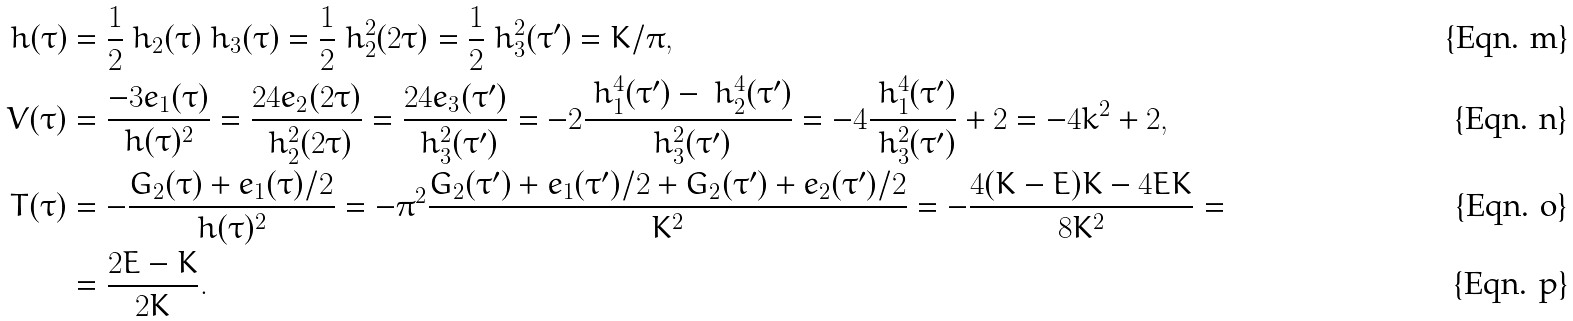<formula> <loc_0><loc_0><loc_500><loc_500>h ( \tau ) & = \frac { 1 } { 2 } \ h _ { 2 } ( \tau ) \ h _ { 3 } ( \tau ) = \frac { 1 } { 2 } \ h _ { 2 } ^ { 2 } ( 2 \tau ) = \frac { 1 } { 2 } \ h _ { 3 } ^ { 2 } ( \tau ^ { \prime } ) = K / \pi , \\ V ( \tau ) & = \frac { - 3 e _ { 1 } ( \tau ) } { h ( \tau ) ^ { 2 } } = \frac { 2 4 e _ { 2 } ( 2 \tau ) } { \ h _ { 2 } ^ { 2 } ( 2 \tau ) } = \frac { 2 4 e _ { 3 } ( \tau ^ { \prime } ) } { \ h _ { 3 } ^ { 2 } ( \tau ^ { \prime } ) } = - 2 \frac { \ h _ { 1 } ^ { 4 } ( \tau ^ { \prime } ) - \ h _ { 2 } ^ { 4 } ( \tau ^ { \prime } ) } { \ h _ { 3 } ^ { 2 } ( \tau ^ { \prime } ) } = - 4 \frac { \ h _ { 1 } ^ { 4 } ( \tau ^ { \prime } ) } { \ h _ { 3 } ^ { 2 } ( \tau ^ { \prime } ) } + 2 = - 4 k ^ { 2 } + 2 , \\ T ( \tau ) & = - \frac { G _ { 2 } ( \tau ) + e _ { 1 } ( \tau ) / 2 } { h ( \tau ) ^ { 2 } } = - \pi ^ { 2 } \frac { G _ { 2 } ( \tau ^ { \prime } ) + e _ { 1 } ( \tau ^ { \prime } ) / 2 + G _ { 2 } ( \tau ^ { \prime } ) + e _ { 2 } ( \tau ^ { \prime } ) / 2 } { K ^ { 2 } } = - \frac { 4 ( K - E ) K - 4 E K } { 8 K ^ { 2 } } = \\ & = \frac { 2 E - K } { 2 K } .</formula> 